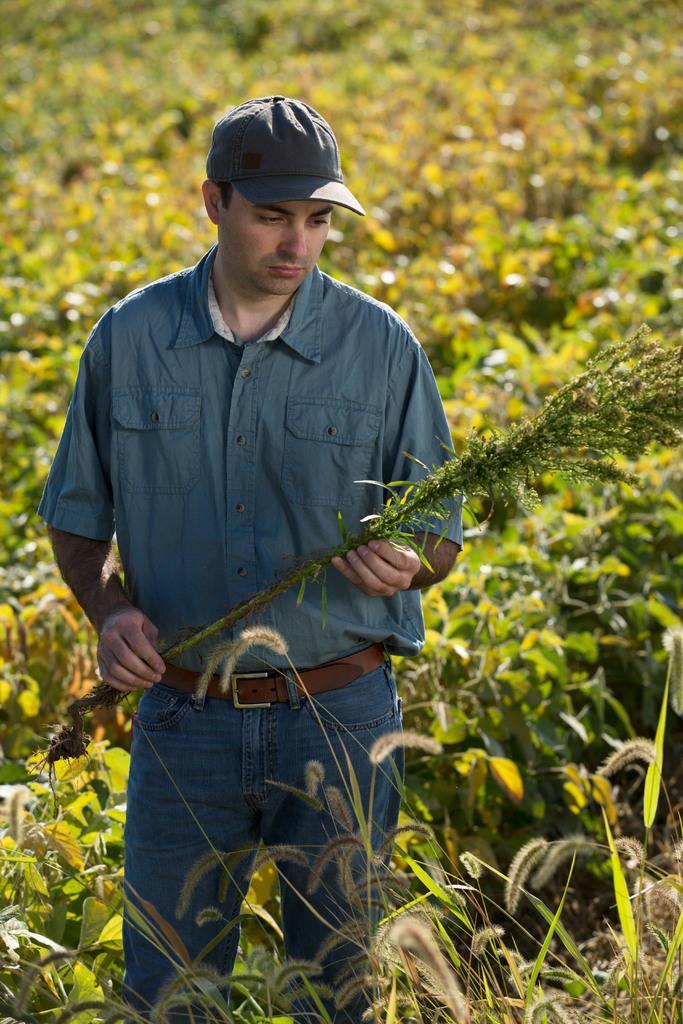Please provide a concise description of this image. In this image I can see a man wearing a cap. In the background I can see a ground full of plant. I can see he is holding a plant. 